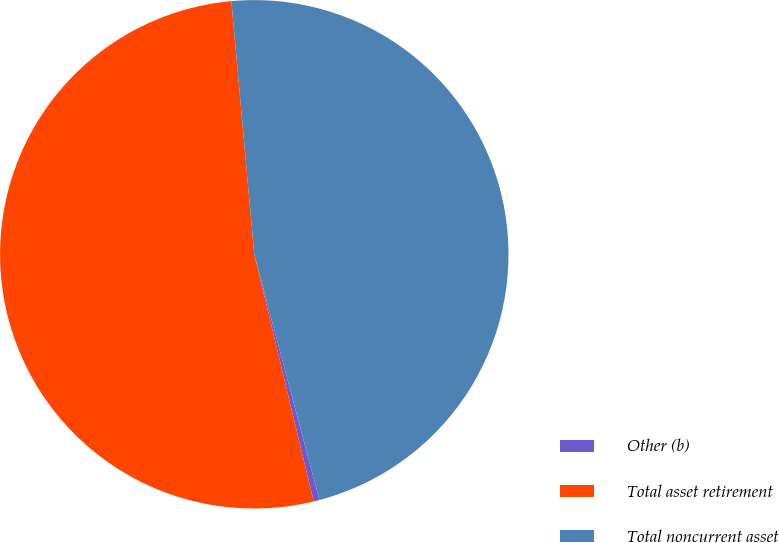Convert chart. <chart><loc_0><loc_0><loc_500><loc_500><pie_chart><fcel>Other (b)<fcel>Total asset retirement<fcel>Total noncurrent asset<nl><fcel>0.37%<fcel>52.32%<fcel>47.31%<nl></chart> 